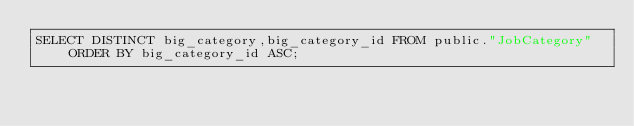<code> <loc_0><loc_0><loc_500><loc_500><_SQL_>SELECT DISTINCT big_category,big_category_id FROM public."JobCategory" ORDER BY big_category_id ASC;</code> 